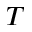Convert formula to latex. <formula><loc_0><loc_0><loc_500><loc_500>T</formula> 